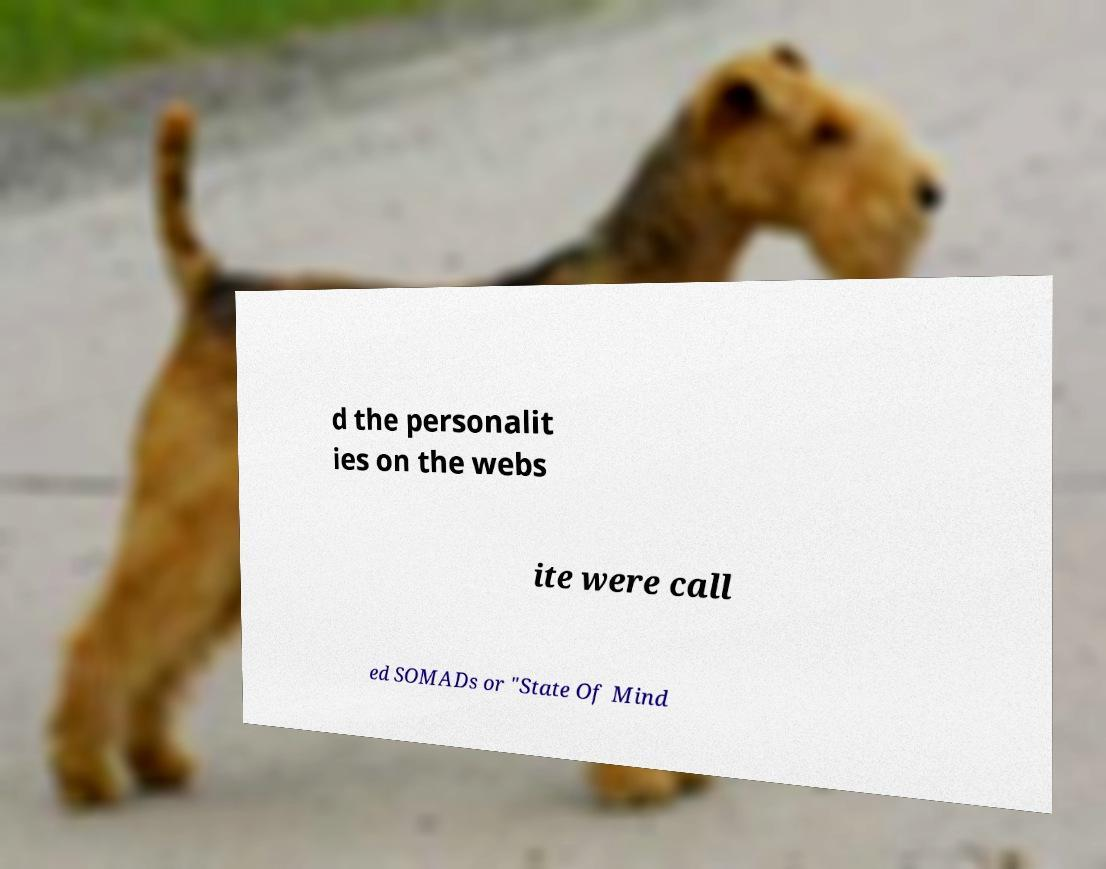Could you assist in decoding the text presented in this image and type it out clearly? d the personalit ies on the webs ite were call ed SOMADs or "State Of Mind 